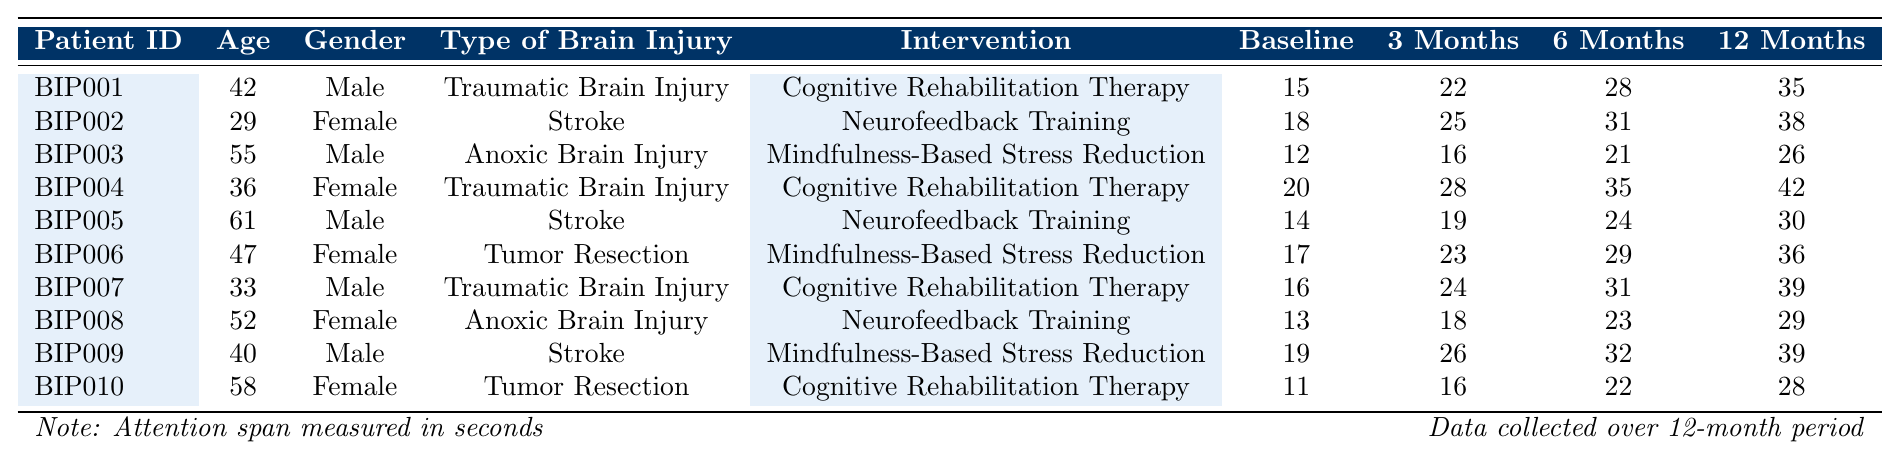What is the attention span of Patient BIP007 at 12 months? To find the attention span for Patient BIP007 after 12 months, we look at the row corresponding to this patient in the table. The value listed under the "12 Months Attention Span" column is 39 seconds.
Answer: 39 seconds What was the baseline attention span for the female patients? We gather the baseline attention spans of all female patients from the table: BIP002 (18), BIP004 (20), BIP006 (17), BIP008 (13), and BIP010 (11). Summing these values gives 18 + 20 + 17 + 13 + 11 = 79 seconds. Dividing by 5 female patients results in an average of 79/5 = 15.8 seconds.
Answer: 15.8 seconds Did any patient show no improvement in their attention span after 12 months? To determine if any patient showed no improvement in attention span, we need to compare the baseline attention span with the 12-month attention span for each patient. All patients have a higher 12-month value than their baseline. Therefore, no patient showed no improvement.
Answer: No Which intervention led to the highest 12-month attention span among the patients? Looking through the "12 Months Attention Span" column for each intervention: Cognitive Rehabilitation Therapy: BIP001 (35), BIP004 (42), BIP010 (28); Neurofeedback Training: BIP002 (38), BIP005 (30), BIP008 (29); Mindfulness-Based Stress Reduction: BIP003 (26), BIP006 (36), BIP009 (39). The maximum value is 42 seconds from BIP004 with Cognitive Rehabilitation Therapy.
Answer: Cognitive Rehabilitation Therapy What is the average increase in attention span for patients undergoing Neurofeedback Training? We find the attention spans of the Neurofeedback Training patients: BIP002: 18 to 38 (20 increase), BIP005: 14 to 30 (16 increase), and BIP008: 13 to 29 (16 increase). Summing these increases gives 20 + 16 + 16 = 52 seconds. Dividing by 3 patients gives an average increase of 52/3 = 17.33 seconds.
Answer: 17.33 seconds How many male patients had a baseline attention span lower than 15 seconds? We check the baseline attention spans of male patients: BIP001 (15), BIP003 (12), BIP005 (14), BIP007 (16), BIP009 (19). Only BIP003 (12) and BIP005 (14) are lower than 15 seconds, which totals to 2 male patients.
Answer: 2 Which patient had the least improvement in attention span after 12 months? We calculate the attention span improvement for each patient by subtracting the baseline from the 12-month value. The least improvement is found by examining the 12-month values: BIP003 improved from 12 to 26 (14 seconds), while all others had improvements greater than 14 seconds. Hence, BIP003 showed the least improvement.
Answer: BIP003 What was the overall trend in attention span improvement across all patients over the 12-month period? Examining the attention spans at baseline and at 12 months, all values increased, indicating a positive trend across all patients. Comparing the total baseline (sum of all) with the total at 12 months confirms this, as totals show an increase.
Answer: Overall improvement 